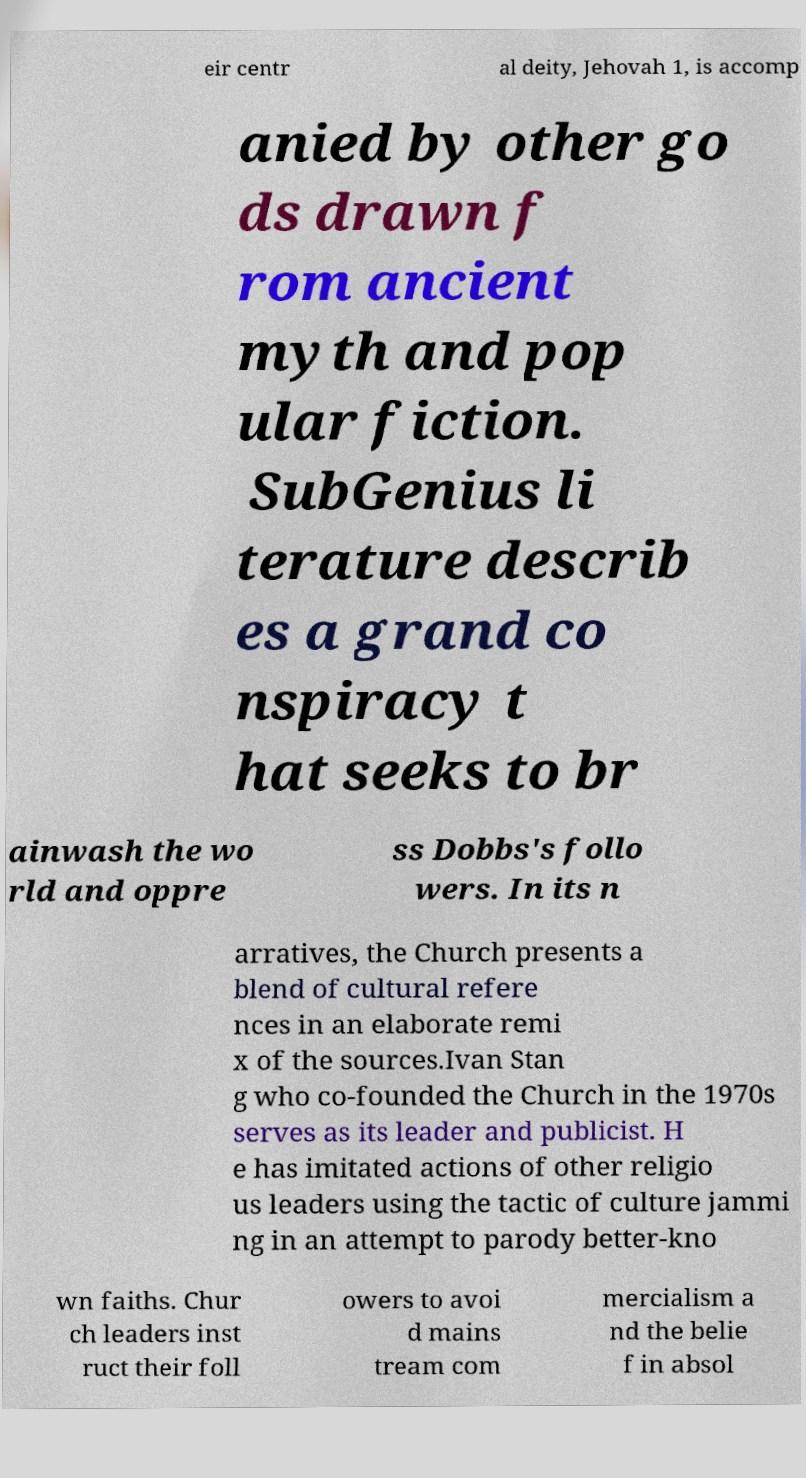Can you read and provide the text displayed in the image?This photo seems to have some interesting text. Can you extract and type it out for me? eir centr al deity, Jehovah 1, is accomp anied by other go ds drawn f rom ancient myth and pop ular fiction. SubGenius li terature describ es a grand co nspiracy t hat seeks to br ainwash the wo rld and oppre ss Dobbs's follo wers. In its n arratives, the Church presents a blend of cultural refere nces in an elaborate remi x of the sources.Ivan Stan g who co-founded the Church in the 1970s serves as its leader and publicist. H e has imitated actions of other religio us leaders using the tactic of culture jammi ng in an attempt to parody better-kno wn faiths. Chur ch leaders inst ruct their foll owers to avoi d mains tream com mercialism a nd the belie f in absol 